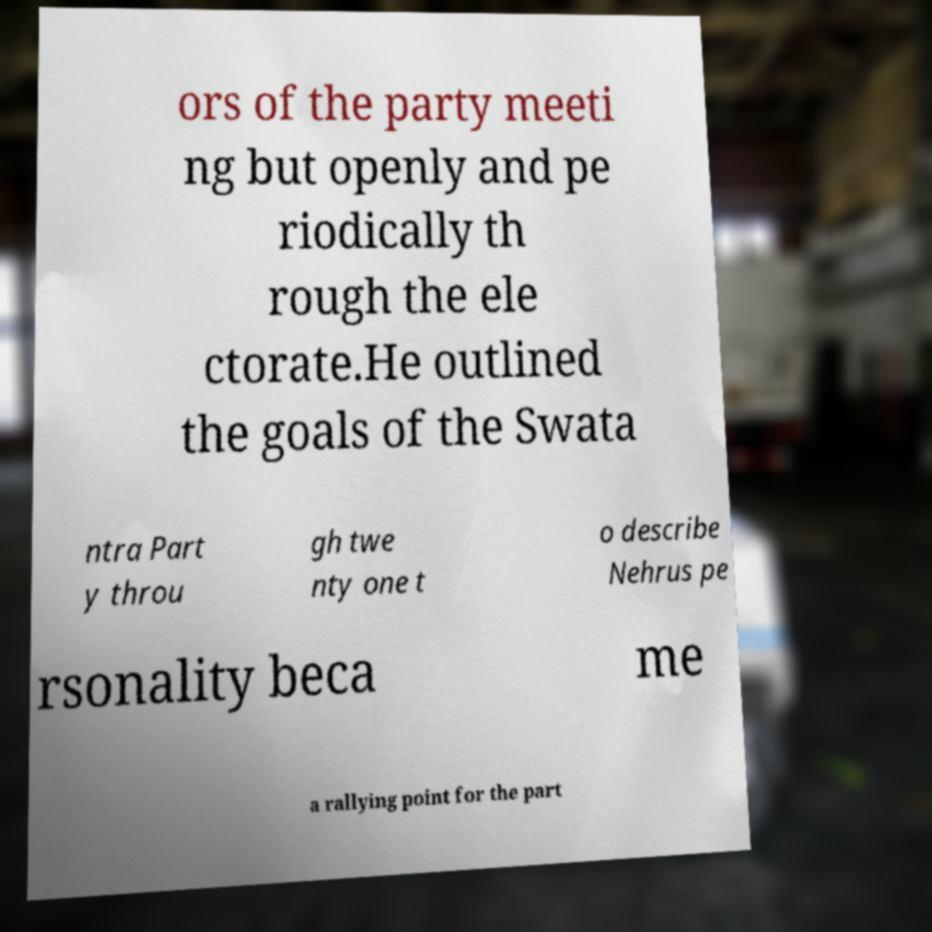I need the written content from this picture converted into text. Can you do that? ors of the party meeti ng but openly and pe riodically th rough the ele ctorate.He outlined the goals of the Swata ntra Part y throu gh twe nty one t o describe Nehrus pe rsonality beca me a rallying point for the part 